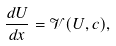Convert formula to latex. <formula><loc_0><loc_0><loc_500><loc_500>\frac { d U } { d x } = \mathcal { V } ( U , c ) ,</formula> 